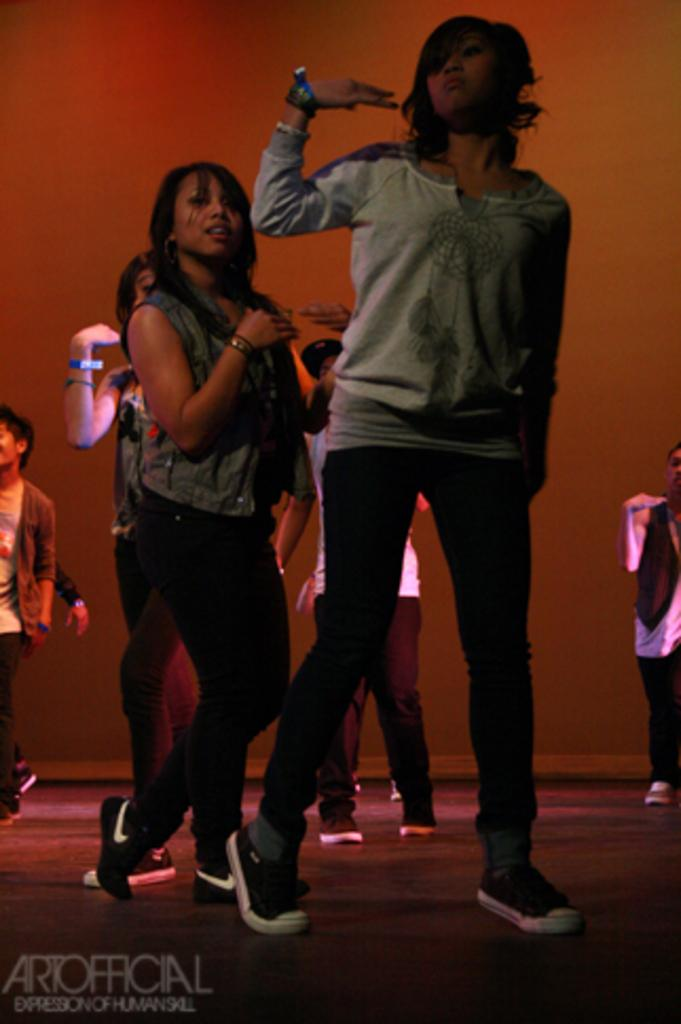What is the main subject of the image? The main subject of the image is a group of people. Where are the people located in the image? The people are standing on the floor. Can you describe the appearance of one of the individuals in the group? There is a woman wearing a grey t-shirt. What additional information can be found at the bottom of the image? There is text visible at the bottom of the image. What type of car is parked next to the group of people in the image? There is no car present in the image; it only features a group of people standing on the floor. 